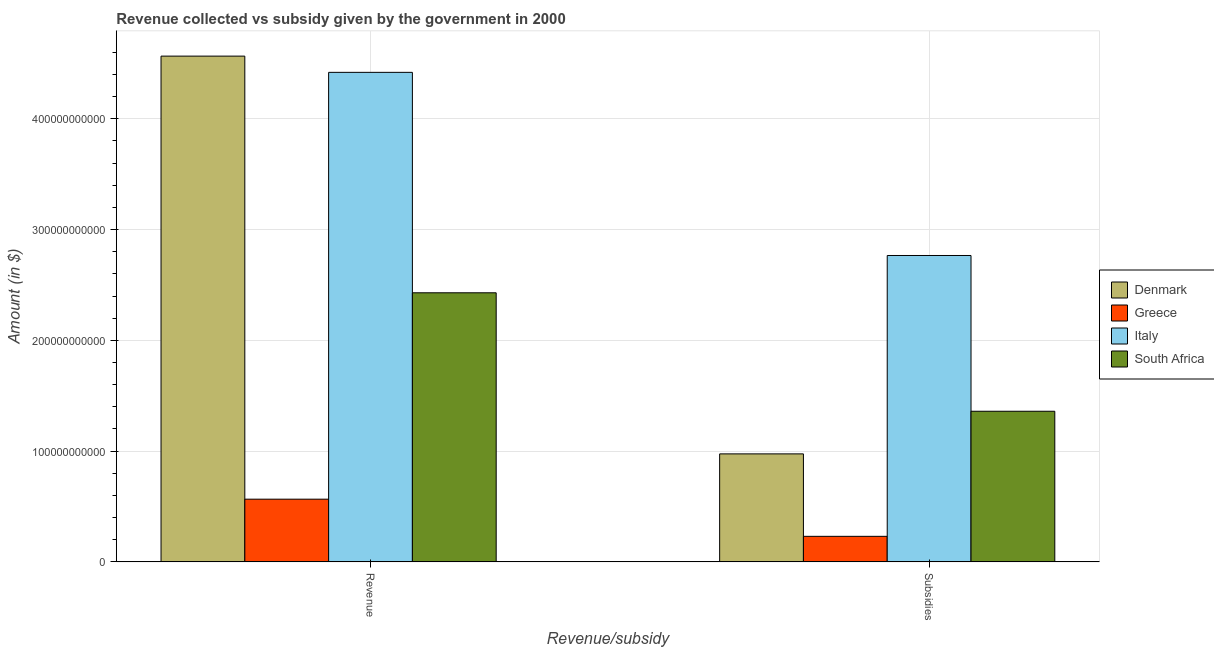How many bars are there on the 2nd tick from the left?
Ensure brevity in your answer.  4. What is the label of the 2nd group of bars from the left?
Offer a very short reply. Subsidies. What is the amount of revenue collected in Greece?
Your response must be concise. 5.66e+1. Across all countries, what is the maximum amount of revenue collected?
Your answer should be compact. 4.57e+11. Across all countries, what is the minimum amount of subsidies given?
Your response must be concise. 2.31e+1. In which country was the amount of revenue collected maximum?
Keep it short and to the point. Denmark. In which country was the amount of subsidies given minimum?
Your answer should be very brief. Greece. What is the total amount of revenue collected in the graph?
Ensure brevity in your answer.  1.20e+12. What is the difference between the amount of subsidies given in Denmark and that in South Africa?
Ensure brevity in your answer.  -3.85e+1. What is the difference between the amount of subsidies given in Denmark and the amount of revenue collected in Greece?
Make the answer very short. 4.09e+1. What is the average amount of revenue collected per country?
Your response must be concise. 3.00e+11. What is the difference between the amount of revenue collected and amount of subsidies given in Italy?
Your answer should be very brief. 1.65e+11. In how many countries, is the amount of revenue collected greater than 440000000000 $?
Your answer should be very brief. 2. What is the ratio of the amount of subsidies given in Italy to that in Greece?
Keep it short and to the point. 11.98. Is the amount of subsidies given in South Africa less than that in Greece?
Offer a terse response. No. In how many countries, is the amount of subsidies given greater than the average amount of subsidies given taken over all countries?
Offer a very short reply. 2. What does the 4th bar from the left in Revenue represents?
Make the answer very short. South Africa. What does the 3rd bar from the right in Revenue represents?
Provide a succinct answer. Greece. Are all the bars in the graph horizontal?
Offer a terse response. No. What is the difference between two consecutive major ticks on the Y-axis?
Give a very brief answer. 1.00e+11. Does the graph contain grids?
Ensure brevity in your answer.  Yes. Where does the legend appear in the graph?
Ensure brevity in your answer.  Center right. What is the title of the graph?
Provide a short and direct response. Revenue collected vs subsidy given by the government in 2000. Does "Belize" appear as one of the legend labels in the graph?
Provide a short and direct response. No. What is the label or title of the X-axis?
Your response must be concise. Revenue/subsidy. What is the label or title of the Y-axis?
Your answer should be compact. Amount (in $). What is the Amount (in $) in Denmark in Revenue?
Make the answer very short. 4.57e+11. What is the Amount (in $) in Greece in Revenue?
Make the answer very short. 5.66e+1. What is the Amount (in $) in Italy in Revenue?
Provide a succinct answer. 4.42e+11. What is the Amount (in $) of South Africa in Revenue?
Provide a succinct answer. 2.43e+11. What is the Amount (in $) of Denmark in Subsidies?
Keep it short and to the point. 9.75e+1. What is the Amount (in $) in Greece in Subsidies?
Make the answer very short. 2.31e+1. What is the Amount (in $) of Italy in Subsidies?
Your answer should be compact. 2.77e+11. What is the Amount (in $) of South Africa in Subsidies?
Ensure brevity in your answer.  1.36e+11. Across all Revenue/subsidy, what is the maximum Amount (in $) in Denmark?
Make the answer very short. 4.57e+11. Across all Revenue/subsidy, what is the maximum Amount (in $) of Greece?
Keep it short and to the point. 5.66e+1. Across all Revenue/subsidy, what is the maximum Amount (in $) of Italy?
Your answer should be compact. 4.42e+11. Across all Revenue/subsidy, what is the maximum Amount (in $) in South Africa?
Keep it short and to the point. 2.43e+11. Across all Revenue/subsidy, what is the minimum Amount (in $) of Denmark?
Your response must be concise. 9.75e+1. Across all Revenue/subsidy, what is the minimum Amount (in $) of Greece?
Provide a short and direct response. 2.31e+1. Across all Revenue/subsidy, what is the minimum Amount (in $) in Italy?
Ensure brevity in your answer.  2.77e+11. Across all Revenue/subsidy, what is the minimum Amount (in $) in South Africa?
Your response must be concise. 1.36e+11. What is the total Amount (in $) in Denmark in the graph?
Offer a very short reply. 5.54e+11. What is the total Amount (in $) in Greece in the graph?
Your response must be concise. 7.97e+1. What is the total Amount (in $) of Italy in the graph?
Provide a succinct answer. 7.19e+11. What is the total Amount (in $) of South Africa in the graph?
Your answer should be very brief. 3.79e+11. What is the difference between the Amount (in $) of Denmark in Revenue and that in Subsidies?
Your response must be concise. 3.59e+11. What is the difference between the Amount (in $) of Greece in Revenue and that in Subsidies?
Ensure brevity in your answer.  3.35e+1. What is the difference between the Amount (in $) of Italy in Revenue and that in Subsidies?
Offer a very short reply. 1.65e+11. What is the difference between the Amount (in $) of South Africa in Revenue and that in Subsidies?
Offer a very short reply. 1.07e+11. What is the difference between the Amount (in $) in Denmark in Revenue and the Amount (in $) in Greece in Subsidies?
Keep it short and to the point. 4.34e+11. What is the difference between the Amount (in $) of Denmark in Revenue and the Amount (in $) of Italy in Subsidies?
Your answer should be very brief. 1.80e+11. What is the difference between the Amount (in $) in Denmark in Revenue and the Amount (in $) in South Africa in Subsidies?
Your answer should be compact. 3.21e+11. What is the difference between the Amount (in $) of Greece in Revenue and the Amount (in $) of Italy in Subsidies?
Offer a very short reply. -2.20e+11. What is the difference between the Amount (in $) in Greece in Revenue and the Amount (in $) in South Africa in Subsidies?
Offer a terse response. -7.94e+1. What is the difference between the Amount (in $) of Italy in Revenue and the Amount (in $) of South Africa in Subsidies?
Make the answer very short. 3.06e+11. What is the average Amount (in $) in Denmark per Revenue/subsidy?
Your answer should be compact. 2.77e+11. What is the average Amount (in $) in Greece per Revenue/subsidy?
Your answer should be very brief. 3.99e+1. What is the average Amount (in $) in Italy per Revenue/subsidy?
Ensure brevity in your answer.  3.59e+11. What is the average Amount (in $) of South Africa per Revenue/subsidy?
Provide a succinct answer. 1.89e+11. What is the difference between the Amount (in $) in Denmark and Amount (in $) in Greece in Revenue?
Give a very brief answer. 4.00e+11. What is the difference between the Amount (in $) in Denmark and Amount (in $) in Italy in Revenue?
Your response must be concise. 1.47e+1. What is the difference between the Amount (in $) in Denmark and Amount (in $) in South Africa in Revenue?
Your answer should be very brief. 2.14e+11. What is the difference between the Amount (in $) of Greece and Amount (in $) of Italy in Revenue?
Your response must be concise. -3.85e+11. What is the difference between the Amount (in $) of Greece and Amount (in $) of South Africa in Revenue?
Offer a very short reply. -1.86e+11. What is the difference between the Amount (in $) in Italy and Amount (in $) in South Africa in Revenue?
Give a very brief answer. 1.99e+11. What is the difference between the Amount (in $) in Denmark and Amount (in $) in Greece in Subsidies?
Provide a short and direct response. 7.44e+1. What is the difference between the Amount (in $) in Denmark and Amount (in $) in Italy in Subsidies?
Your answer should be very brief. -1.79e+11. What is the difference between the Amount (in $) of Denmark and Amount (in $) of South Africa in Subsidies?
Make the answer very short. -3.85e+1. What is the difference between the Amount (in $) in Greece and Amount (in $) in Italy in Subsidies?
Offer a terse response. -2.54e+11. What is the difference between the Amount (in $) in Greece and Amount (in $) in South Africa in Subsidies?
Keep it short and to the point. -1.13e+11. What is the difference between the Amount (in $) in Italy and Amount (in $) in South Africa in Subsidies?
Your answer should be compact. 1.41e+11. What is the ratio of the Amount (in $) of Denmark in Revenue to that in Subsidies?
Provide a succinct answer. 4.68. What is the ratio of the Amount (in $) of Greece in Revenue to that in Subsidies?
Ensure brevity in your answer.  2.45. What is the ratio of the Amount (in $) of Italy in Revenue to that in Subsidies?
Ensure brevity in your answer.  1.6. What is the ratio of the Amount (in $) in South Africa in Revenue to that in Subsidies?
Give a very brief answer. 1.79. What is the difference between the highest and the second highest Amount (in $) of Denmark?
Ensure brevity in your answer.  3.59e+11. What is the difference between the highest and the second highest Amount (in $) in Greece?
Provide a succinct answer. 3.35e+1. What is the difference between the highest and the second highest Amount (in $) of Italy?
Offer a very short reply. 1.65e+11. What is the difference between the highest and the second highest Amount (in $) of South Africa?
Provide a short and direct response. 1.07e+11. What is the difference between the highest and the lowest Amount (in $) of Denmark?
Provide a succinct answer. 3.59e+11. What is the difference between the highest and the lowest Amount (in $) of Greece?
Keep it short and to the point. 3.35e+1. What is the difference between the highest and the lowest Amount (in $) in Italy?
Offer a very short reply. 1.65e+11. What is the difference between the highest and the lowest Amount (in $) in South Africa?
Your response must be concise. 1.07e+11. 